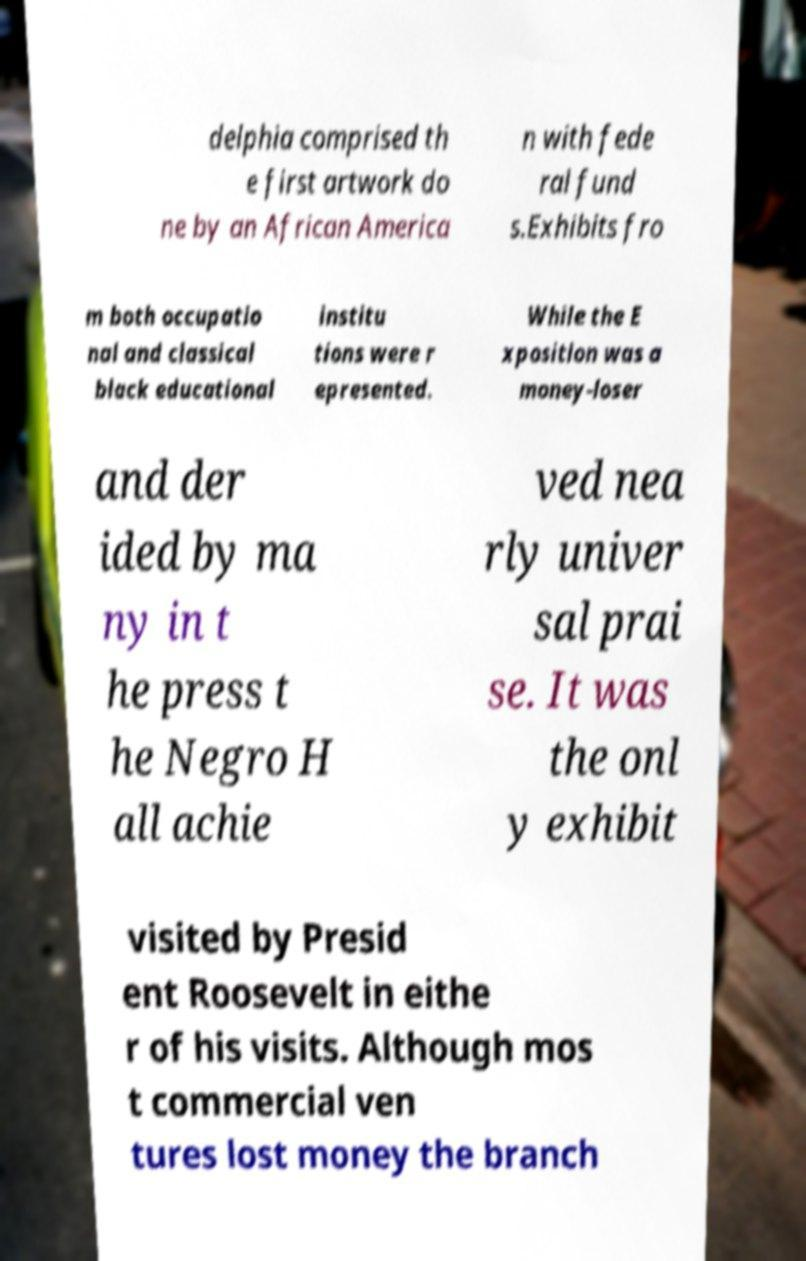There's text embedded in this image that I need extracted. Can you transcribe it verbatim? delphia comprised th e first artwork do ne by an African America n with fede ral fund s.Exhibits fro m both occupatio nal and classical black educational institu tions were r epresented. While the E xposition was a money-loser and der ided by ma ny in t he press t he Negro H all achie ved nea rly univer sal prai se. It was the onl y exhibit visited by Presid ent Roosevelt in eithe r of his visits. Although mos t commercial ven tures lost money the branch 